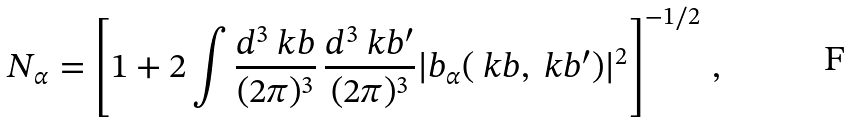Convert formula to latex. <formula><loc_0><loc_0><loc_500><loc_500>N _ { \alpha } = \left [ 1 + 2 \int \frac { d ^ { 3 } \ k b } { ( 2 \pi ) ^ { 3 } } \, \frac { d ^ { 3 } \ k b ^ { \prime } } { ( 2 \pi ) ^ { 3 } } | b _ { \alpha } ( \ k b , \ k b ^ { \prime } ) | ^ { 2 } \right ] ^ { - 1 / 2 } \, ,</formula> 